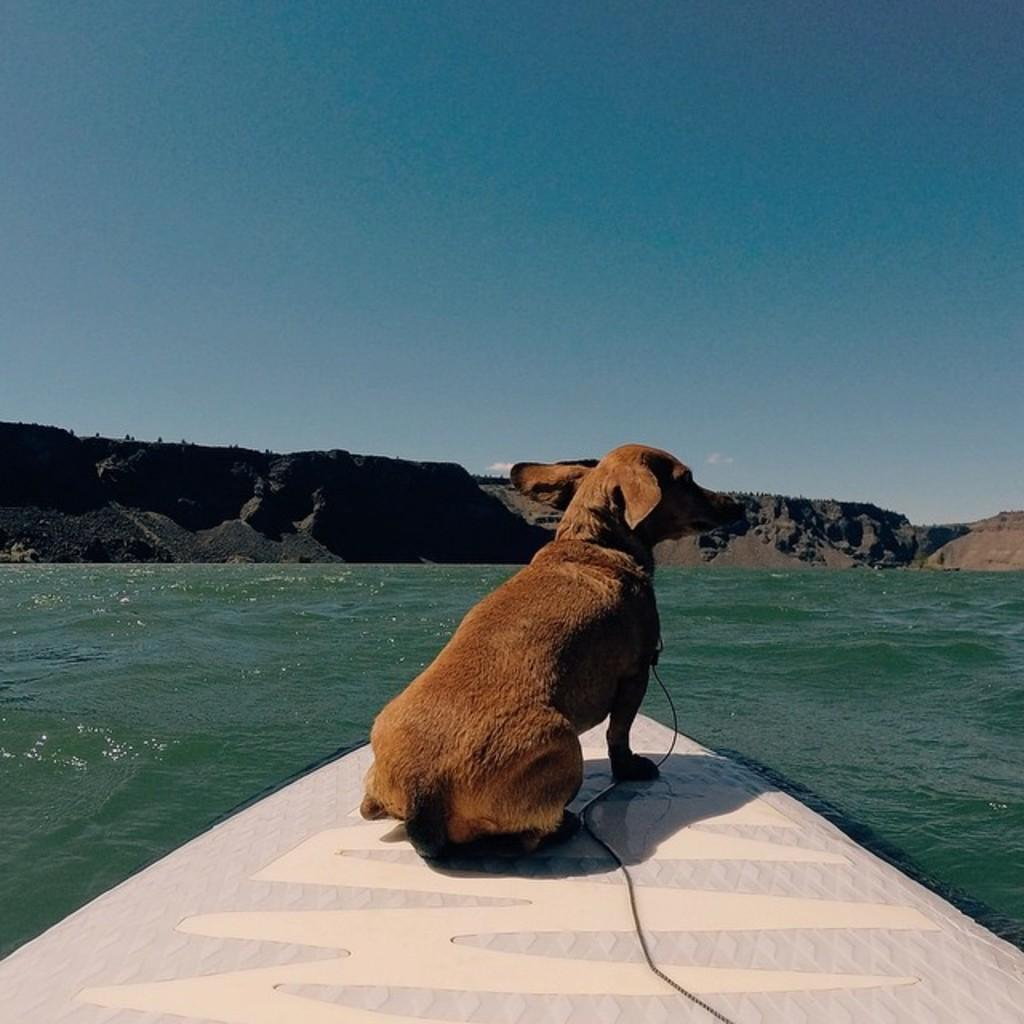What animal can be seen in the image? There is a dog in the image. What is the dog sitting on? The dog is sitting on a board. What type of environment is visible in the image? There is water and mountains visible in the image. What is visible at the top of the image? The sky is visible at the top of the image. What type of skin condition does the dog have in the image? There is no indication of a skin condition on the dog in the image. What song is the dog singing in the image? Dogs do not sing songs, and there is no indication of any song being sung in the image. 